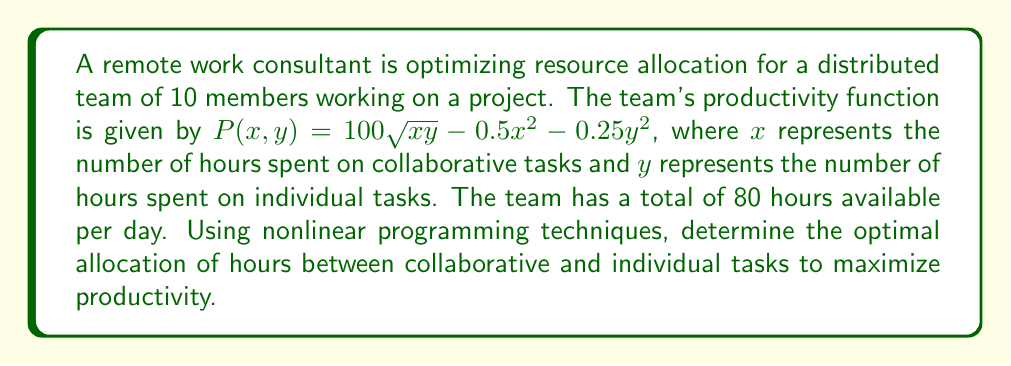Teach me how to tackle this problem. To solve this optimization problem, we'll use the method of Lagrange multipliers:

1) Define the objective function:
   $P(x,y) = 100\sqrt{xy} - 0.5x^2 - 0.25y^2$

2) Define the constraint:
   $g(x,y) = x + y - 80 = 0$

3) Form the Lagrangian:
   $L(x,y,\lambda) = 100\sqrt{xy} - 0.5x^2 - 0.25y^2 - \lambda(x + y - 80)$

4) Calculate partial derivatives and set them to zero:
   $\frac{\partial L}{\partial x} = \frac{50y}{\sqrt{xy}} - x - \lambda = 0$
   $\frac{\partial L}{\partial y} = \frac{50x}{\sqrt{xy}} - 0.5y - \lambda = 0$
   $\frac{\partial L}{\partial \lambda} = x + y - 80 = 0$

5) From the first two equations:
   $\frac{50y}{\sqrt{xy}} - x = \frac{50x}{\sqrt{xy}} - 0.5y$
   
   Simplifying:
   $100y - 2x\sqrt{xy} = 100x - y\sqrt{xy}$
   $100y - 100x = 2x\sqrt{xy} - y\sqrt{xy}$
   $100(y - x) = \sqrt{xy}(2x - y)$

6) Square both sides:
   $10000(y - x)^2 = xy(2x - y)^2$

7) Substitute $y = 80 - x$ from the constraint:
   $10000(80 - 2x)^2 = x(80-x)(2x - (80-x))^2$
   $10000(80 - 2x)^2 = x(80-x)(3x - 80)^2$

8) Solve this equation numerically (e.g., using Newton's method):
   $x \approx 40$

9) Substitute back to find $y$:
   $y = 80 - x = 40$

Therefore, the optimal allocation is 40 hours for collaborative tasks and 40 hours for individual tasks.
Answer: $x = 40, y = 40$ 